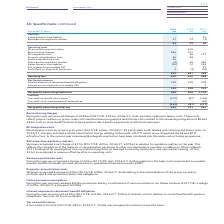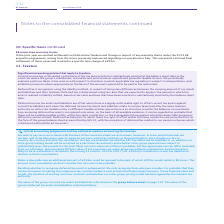According to Bt Group Plc's financial document, What were the restructuring chares in 2019? According to the financial document, £386m. The relevant text states: "ing charges During the year we incurred charges of £386m (2017/18: £241m, 2016/17: £nil), primarily relating to leaver costs. These costs reflect projects wi..." Also, What were the EE integration costs incurred in prior years? (2017/18: £46m, 2016/17: £215m). The document states: "costs EE integration costs incurred in prior years (2017/18: £46m, 2016/17: £215m) relate to EE related restructuring and leaver costs. In 2016/17, th..." Also, What was the pension equilisation cost related to? high court requirement to equalise pension benefits between men and women due to guaranteed minimum pension (GMP).. The document states: "(2017/18: £nil, 2016/17: £nil) in relation to the high court requirement to equalise pension benefits between men and women due to guaranteed minimum ..." Also, can you calculate: What is the change in the Retrospective regulatory matters from 2018 to 2019? Based on the calculation: 31 - 23, the result is 8 (in millions). This is based on the information: "gation – – 22 Retrospective regulatory matters 31 23 (2) stigation – – 22 Retrospective regulatory matters 31 23 (2)..." The key data points involved are: 23, 31. Also, can you calculate: What is the percentage change in the Property rationalisation costs from 2018 to 2019? To answer this question, I need to perform calculations using the financial data. The calculation is: 36 / 28 - 1, which equals 28.57 (percentage). This is based on the information: "costs – 46 215 Property rationalisation costs 36 28 – Pension equalisation costs 26 – – Retrospective regulatory matters (4) 26 481 Italian business in ion costs – 46 215 Property rationalisation cost..." The key data points involved are: 36. Also, can you calculate: What is the average Restructuring charges for 2017-2019? To answer this question, I need to perform calculations using the financial data. The calculation is: (386 + 241 + 0) / 3, which equals 209 (in millions). This is based on the information: "ion warranty claims – 225 – Restructuring charges 386 241 – EE integration costs – 46 215 Property rationalisation costs 36 28 – Pension equalisation cos BT Group plc Annual Report 2019 warranty claim..." The key data points involved are: 241, 386. 